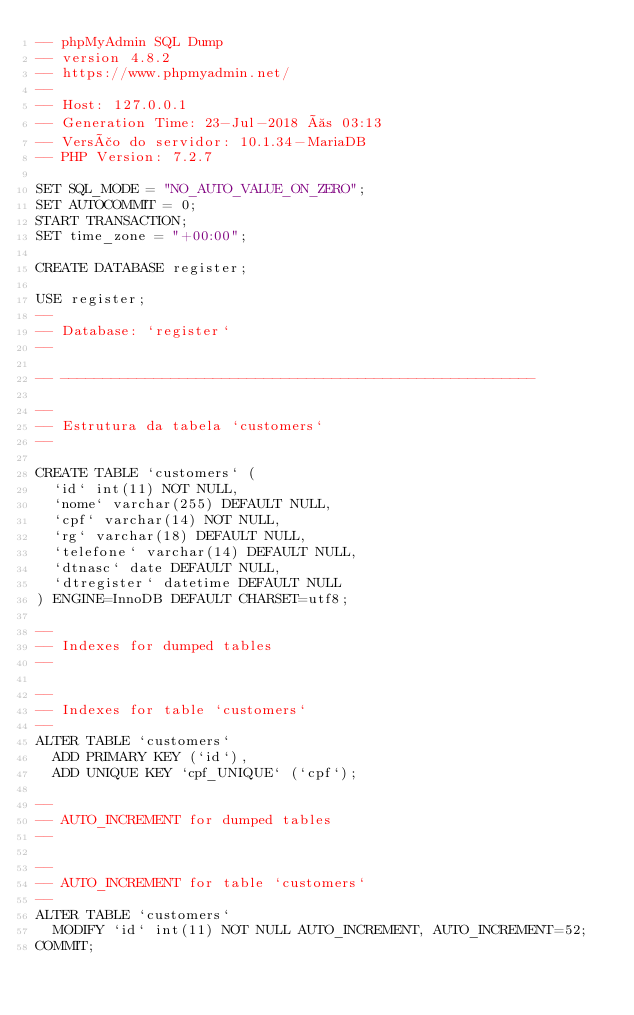<code> <loc_0><loc_0><loc_500><loc_500><_SQL_>-- phpMyAdmin SQL Dump
-- version 4.8.2
-- https://www.phpmyadmin.net/
--
-- Host: 127.0.0.1
-- Generation Time: 23-Jul-2018 às 03:13
-- Versão do servidor: 10.1.34-MariaDB
-- PHP Version: 7.2.7

SET SQL_MODE = "NO_AUTO_VALUE_ON_ZERO";
SET AUTOCOMMIT = 0;
START TRANSACTION;
SET time_zone = "+00:00";

CREATE DATABASE	register;

USE register;
--
-- Database: `register`
--

-- --------------------------------------------------------

--
-- Estrutura da tabela `customers`
--

CREATE TABLE `customers` (
  `id` int(11) NOT NULL,
  `nome` varchar(255) DEFAULT NULL,
  `cpf` varchar(14) NOT NULL,
  `rg` varchar(18) DEFAULT NULL,
  `telefone` varchar(14) DEFAULT NULL,
  `dtnasc` date DEFAULT NULL,
  `dtregister` datetime DEFAULT NULL
) ENGINE=InnoDB DEFAULT CHARSET=utf8;

--
-- Indexes for dumped tables
--

--
-- Indexes for table `customers`
--
ALTER TABLE `customers`
  ADD PRIMARY KEY (`id`),
  ADD UNIQUE KEY `cpf_UNIQUE` (`cpf`);

--
-- AUTO_INCREMENT for dumped tables
--

--
-- AUTO_INCREMENT for table `customers`
--
ALTER TABLE `customers`
  MODIFY `id` int(11) NOT NULL AUTO_INCREMENT, AUTO_INCREMENT=52;
COMMIT;

</code> 